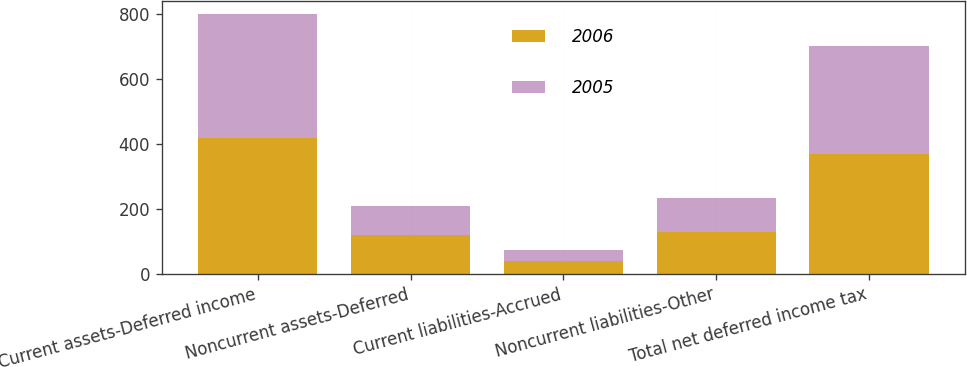Convert chart to OTSL. <chart><loc_0><loc_0><loc_500><loc_500><stacked_bar_chart><ecel><fcel>Current assets-Deferred income<fcel>Noncurrent assets-Deferred<fcel>Current liabilities-Accrued<fcel>Noncurrent liabilities-Other<fcel>Total net deferred income tax<nl><fcel>2006<fcel>417.2<fcel>118.6<fcel>38.1<fcel>128.2<fcel>369.5<nl><fcel>2005<fcel>383.1<fcel>91.1<fcel>35.8<fcel>104.8<fcel>333.6<nl></chart> 